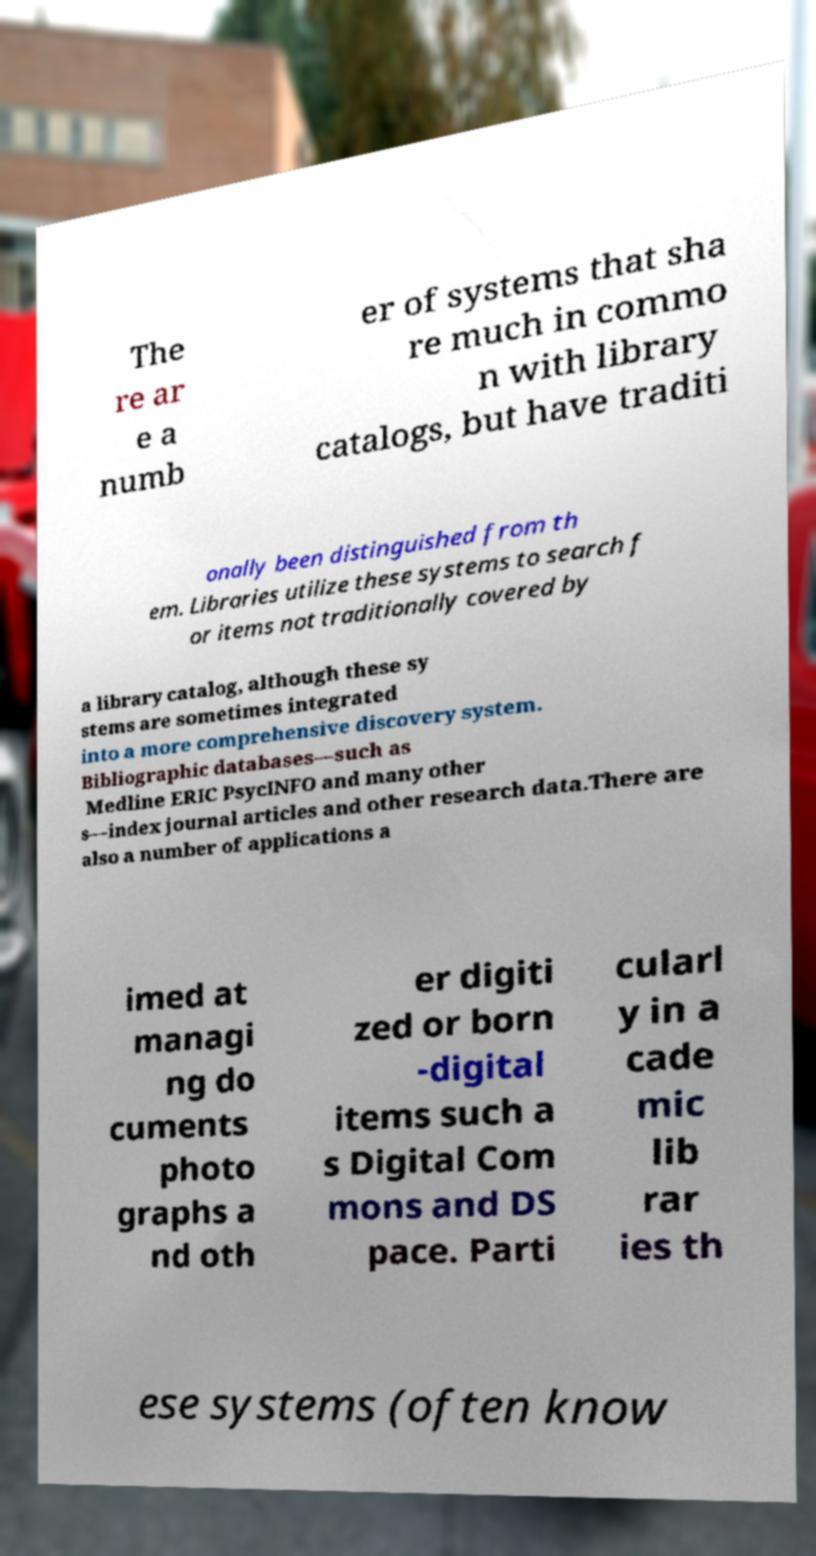Can you accurately transcribe the text from the provided image for me? The re ar e a numb er of systems that sha re much in commo n with library catalogs, but have traditi onally been distinguished from th em. Libraries utilize these systems to search f or items not traditionally covered by a library catalog, although these sy stems are sometimes integrated into a more comprehensive discovery system. Bibliographic databases—such as Medline ERIC PsycINFO and many other s—index journal articles and other research data.There are also a number of applications a imed at managi ng do cuments photo graphs a nd oth er digiti zed or born -digital items such a s Digital Com mons and DS pace. Parti cularl y in a cade mic lib rar ies th ese systems (often know 